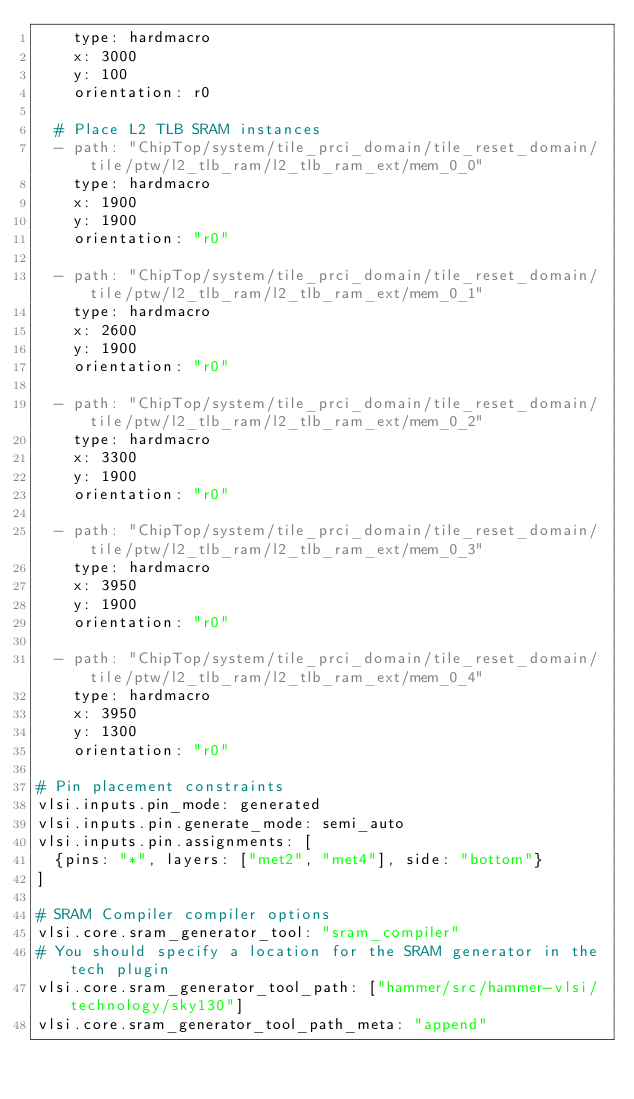<code> <loc_0><loc_0><loc_500><loc_500><_YAML_>    type: hardmacro
    x: 3000
    y: 100
    orientation: r0

  # Place L2 TLB SRAM instances
  - path: "ChipTop/system/tile_prci_domain/tile_reset_domain/tile/ptw/l2_tlb_ram/l2_tlb_ram_ext/mem_0_0"
    type: hardmacro
    x: 1900
    y: 1900
    orientation: "r0"

  - path: "ChipTop/system/tile_prci_domain/tile_reset_domain/tile/ptw/l2_tlb_ram/l2_tlb_ram_ext/mem_0_1"
    type: hardmacro
    x: 2600
    y: 1900
    orientation: "r0"
 
  - path: "ChipTop/system/tile_prci_domain/tile_reset_domain/tile/ptw/l2_tlb_ram/l2_tlb_ram_ext/mem_0_2"
    type: hardmacro
    x: 3300
    y: 1900
    orientation: "r0"

  - path: "ChipTop/system/tile_prci_domain/tile_reset_domain/tile/ptw/l2_tlb_ram/l2_tlb_ram_ext/mem_0_3"
    type: hardmacro
    x: 3950
    y: 1900
    orientation: "r0"

  - path: "ChipTop/system/tile_prci_domain/tile_reset_domain/tile/ptw/l2_tlb_ram/l2_tlb_ram_ext/mem_0_4"
    type: hardmacro
    x: 3950
    y: 1300
    orientation: "r0"

# Pin placement constraints
vlsi.inputs.pin_mode: generated
vlsi.inputs.pin.generate_mode: semi_auto
vlsi.inputs.pin.assignments: [
  {pins: "*", layers: ["met2", "met4"], side: "bottom"}
]

# SRAM Compiler compiler options
vlsi.core.sram_generator_tool: "sram_compiler"
# You should specify a location for the SRAM generator in the tech plugin
vlsi.core.sram_generator_tool_path: ["hammer/src/hammer-vlsi/technology/sky130"]
vlsi.core.sram_generator_tool_path_meta: "append"
</code> 